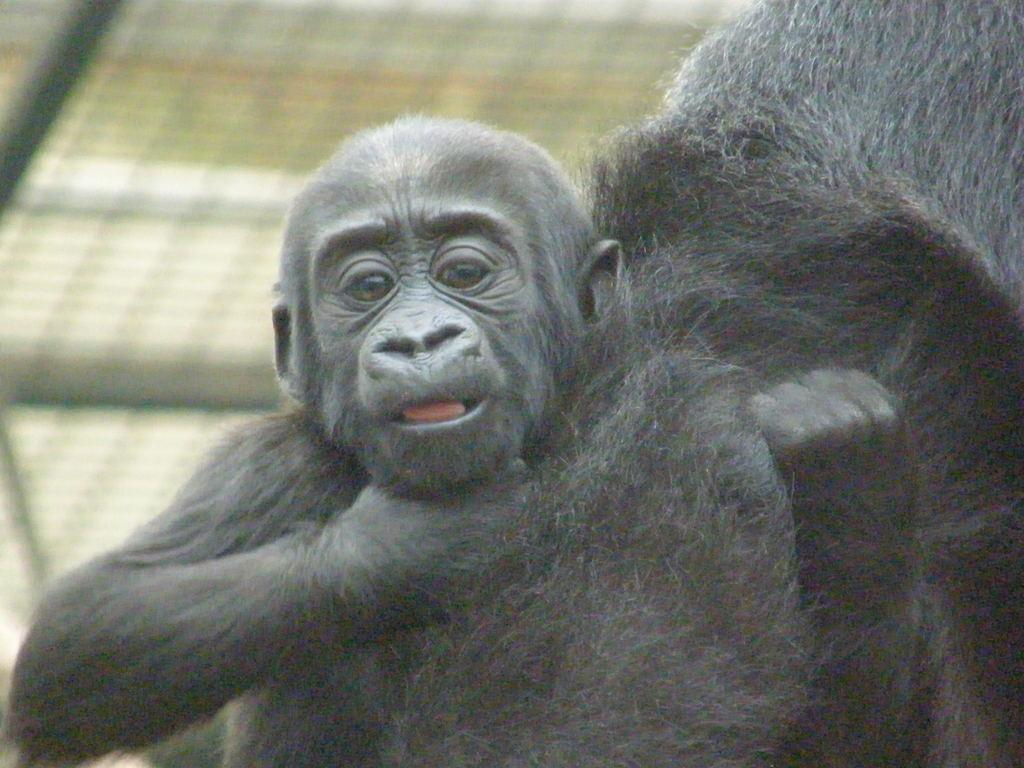What animals are present in the image? There are two chimpanzees in the image. What is the primary feature that separates the chimpanzees from the surrounding area? There is a fence visible in the image. What type of music can be heard playing in the background of the image? There is no music present in the image, as it features two chimpanzees and a fence. 